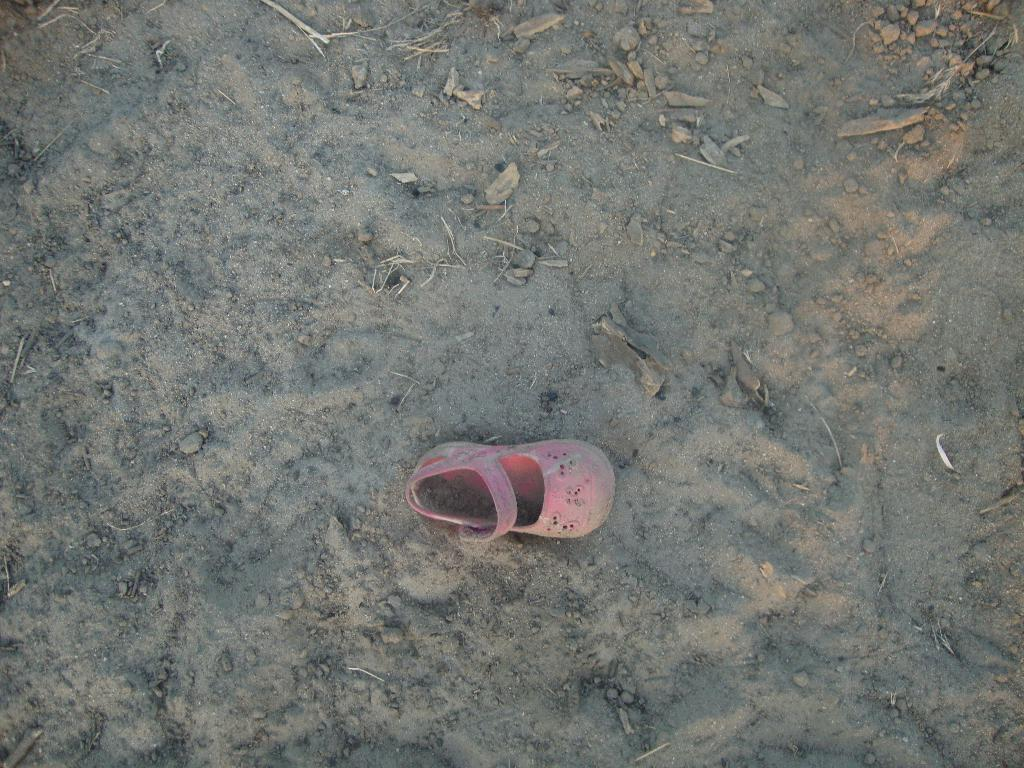What type of footwear is visible in the image? There is footwear in the image, and it is pink in color. What can be seen in the background of the image? There is sand and stones visible in the background of the image. How many cats are sitting on the finger in the image? There are no cats or fingers present in the image. 